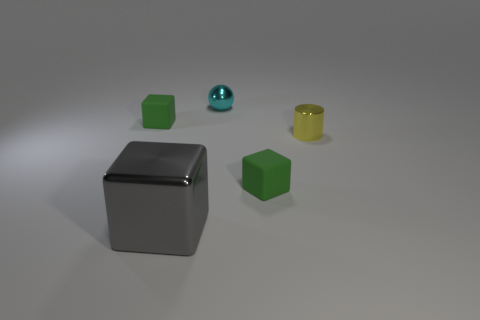Are there the same number of tiny cyan metallic things and small cyan rubber objects?
Offer a terse response. No. There is a matte thing that is in front of the yellow shiny thing; is it the same size as the tiny cyan metal thing?
Your response must be concise. Yes. What number of other things are the same size as the yellow shiny cylinder?
Give a very brief answer. 3. The ball has what color?
Your answer should be very brief. Cyan. There is a small green thing that is behind the small metal cylinder; what is it made of?
Your response must be concise. Rubber. Are there an equal number of metallic cubes behind the yellow object and small matte objects?
Ensure brevity in your answer.  No. Is the shape of the small yellow thing the same as the large gray metal thing?
Your answer should be very brief. No. Is there anything else that is the same color as the large block?
Offer a very short reply. No. What shape is the thing that is both on the right side of the big object and in front of the yellow thing?
Offer a terse response. Cube. Are there the same number of large cubes that are left of the yellow thing and tiny cyan metallic balls left of the gray metal block?
Your answer should be very brief. No. 